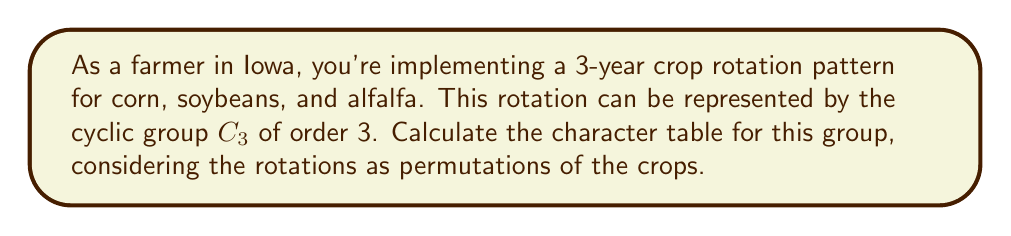Solve this math problem. Let's approach this step-by-step:

1) First, we need to identify the elements of the group $C_3$. Let's denote them as:
   $e$ (identity), $r$ (120° rotation), and $r^2$ (240° rotation)

2) $C_3$ has 3 conjugacy classes, each containing one element: $\{e\}$, $\{r\}$, and $\{r^2\}$

3) The number of irreducible representations is equal to the number of conjugacy classes, so we'll have 3 irreducible representations.

4) For a cyclic group of order 3, the irreducible representations are:
   - The trivial representation: $\chi_0(g) = 1$ for all $g \in C_3$
   - Two 1-dimensional representations: $\chi_1$ and $\chi_2$

5) For $\chi_1$ and $\chi_2$, we use the formula $\chi_j(r^k) = e^{2\pi ijk/3}$ where $i$ is the imaginary unit:
   $\chi_1(r) = e^{2\pi i/3} = -\frac{1}{2} + i\frac{\sqrt{3}}{2}$
   $\chi_1(r^2) = e^{4\pi i/3} = -\frac{1}{2} - i\frac{\sqrt{3}}{2}$
   $\chi_2(r) = e^{4\pi i/3} = -\frac{1}{2} - i\frac{\sqrt{3}}{2}$
   $\chi_2(r^2) = e^{2\pi i/3} = -\frac{1}{2} + i\frac{\sqrt{3}}{2}$

6) Now we can construct the character table:

   $$
   \begin{array}{c|ccc}
    C_3 & e & r & r^2 \\
    \hline
    \chi_0 & 1 & 1 & 1 \\
    \chi_1 & 1 & \omega & \omega^2 \\
    \chi_2 & 1 & \omega^2 & \omega
   \end{array}
   $$

   Where $\omega = e^{2\pi i/3} = -\frac{1}{2} + i\frac{\sqrt{3}}{2}$ and $\omega^2 = e^{4\pi i/3} = -\frac{1}{2} - i\frac{\sqrt{3}}{2}$
Answer: $$
\begin{array}{c|ccc}
C_3 & e & r & r^2 \\
\hline
\chi_0 & 1 & 1 & 1 \\
\chi_1 & 1 & \omega & \omega^2 \\
\chi_2 & 1 & \omega^2 & \omega
\end{array}
$$
where $\omega = e^{2\pi i/3}$ 